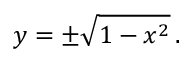<formula> <loc_0><loc_0><loc_500><loc_500>y = \pm { \sqrt { 1 - x ^ { 2 } } } \, .</formula> 